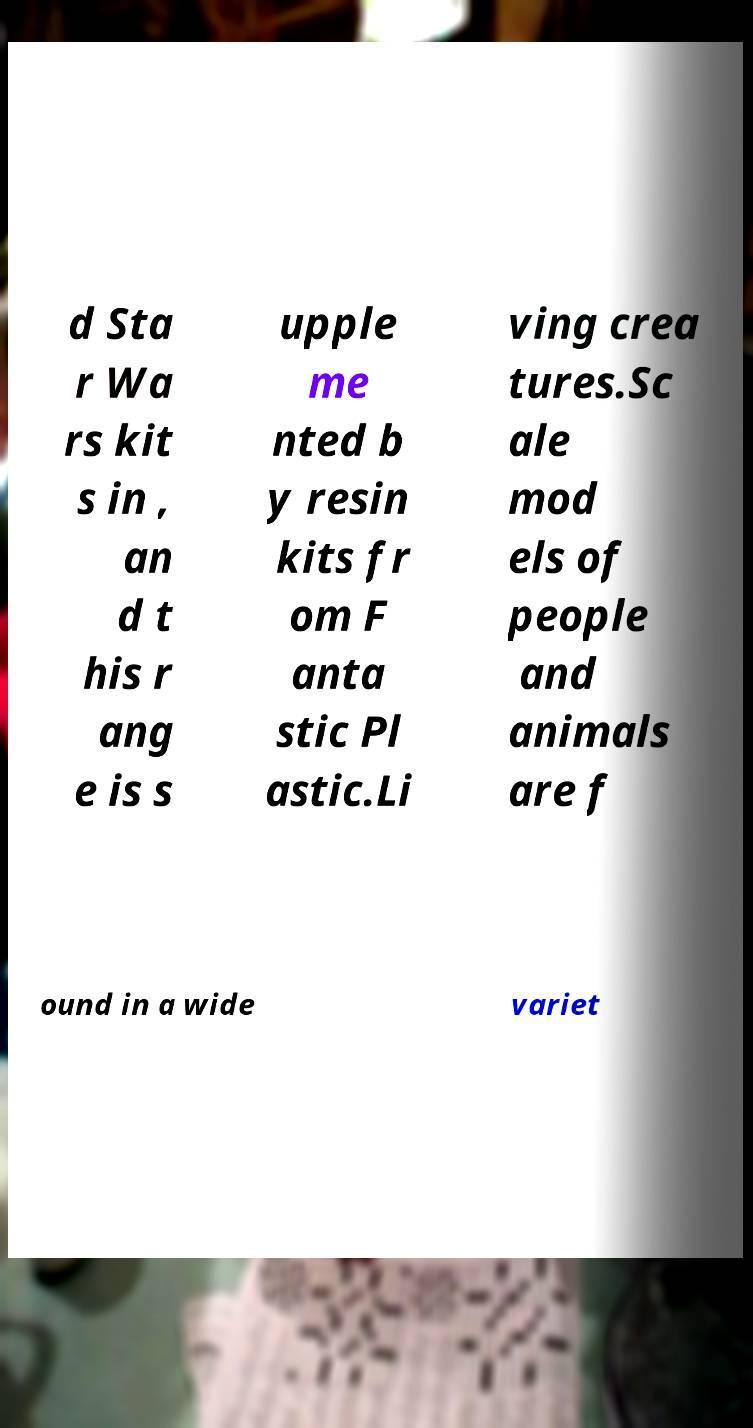For documentation purposes, I need the text within this image transcribed. Could you provide that? d Sta r Wa rs kit s in , an d t his r ang e is s upple me nted b y resin kits fr om F anta stic Pl astic.Li ving crea tures.Sc ale mod els of people and animals are f ound in a wide variet 